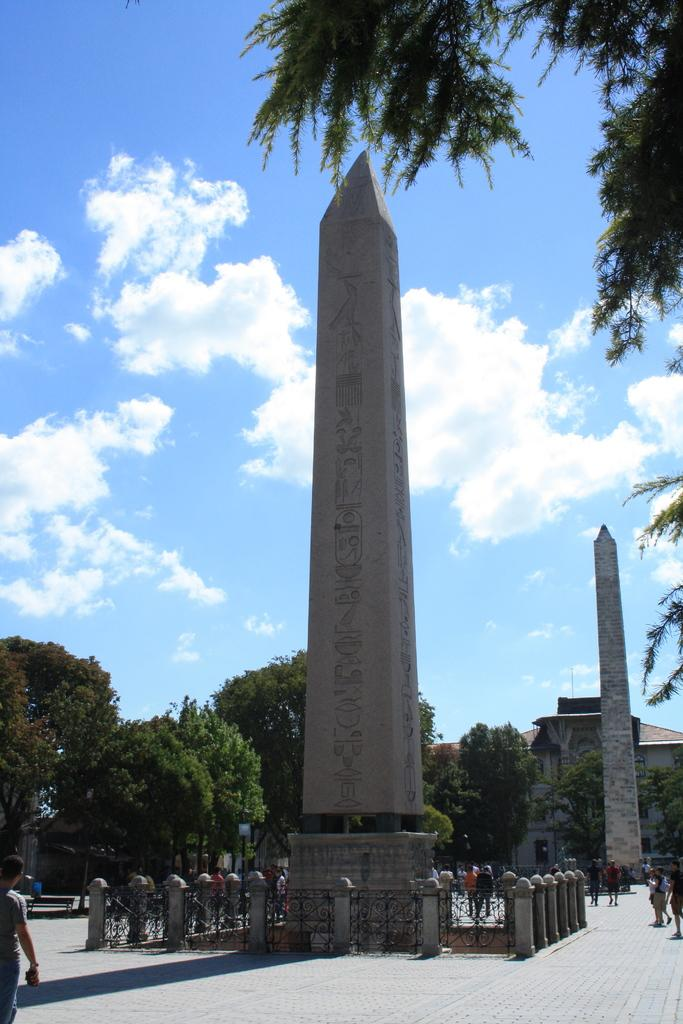What structures are present in the image? There are two obelisks in the image. What can be seen in the background of the image? There are trees and clouds in the sky in the background of the image. What type of hose is being used to water the obelisks in the image? There is no hose present in the image, and the obelisks are not being watered. 